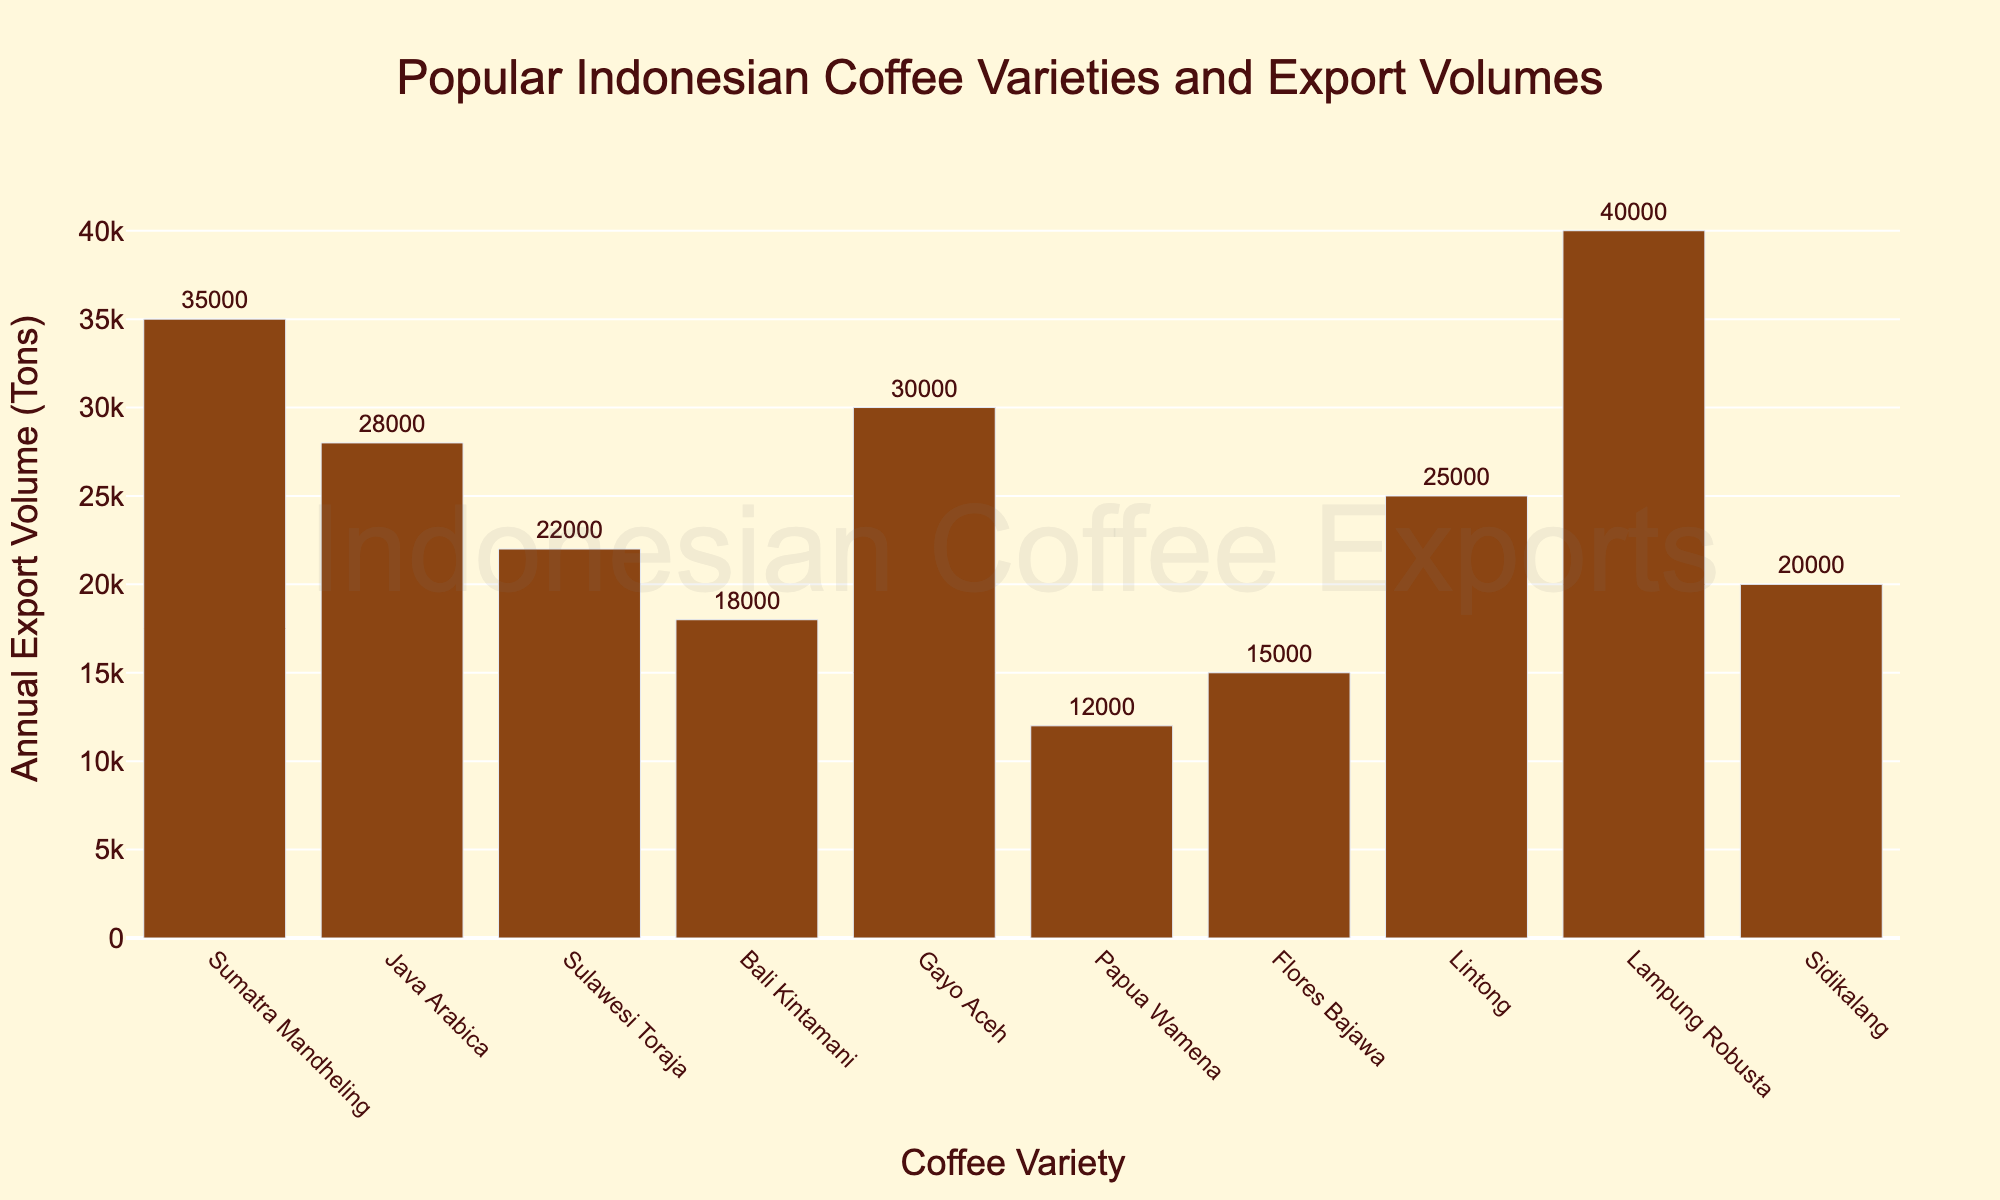Which coffee variety has the highest annual export volume? The bar representing Lampung Robusta is the tallest among all bars, indicating it has the highest export volume.
Answer: Lampung Robusta What's the difference in export volume between Sumatra Mandheling and Sulawesi Toraja? Sumatra Mandheling has an export volume of 35,000 tons and Sulawesi Toraja has 22,000 tons. Subtract the smaller value from the larger one: 35,000 - 22,000 = 13,000.
Answer: 13,000 tons Which coffee varieties have an export volume greater than 30,000 tons? From the chart, Sumatra Mandheling (35,000 tons), Gayo Aceh (30,000 tons), and Lampung Robusta (40,000 tons) have export volumes above 30,000 tons.
Answer: Sumatra Mandheling, Gayo Aceh, Lampung Robusta How does the export volume of Java Arabica compare to Lintong? Java Arabica has an export volume of 28,000 tons, whereas Lintong has 25,000 tons. Java Arabica's export volume is higher by 3,000 tons.
Answer: Java Arabica is 3,000 tons more What is the total export volume for Bali Kintamani and Sidikalang combined? Bali Kintamani has an export volume of 18,000 tons and Sidikalang has 20,000 tons. Adding these together gives 18,000 + 20,000 = 38,000 tons.
Answer: 38,000 tons On average, how many tons do the listed coffee varieties export annually? Summing up all the export volumes (35,000 + 28,000 + 22,000 + 18,000 + 30,000 + 12,000 + 15,000 + 25,000 + 40,000 + 20,000 = 245,000) and dividing by the number of varieties (10), gives an average of 245,000 / 10 = 24,500 tons.
Answer: 24,500 tons Which variety has the shortest bar in the chart and what is its export volume? The shortest bar represents Papua Wamena, which has the lowest export volume of 12,000 tons.
Answer: Papua Wamena, 12,000 tons How much more does Lampung Robusta export annually compared to Bali Kintamani? Lampung Robusta's export volume is 40,000 tons, and Bali Kintamani's is 18,000 tons. The difference is 40,000 - 18,000 = 22,000 tons.
Answer: 22,000 tons If Sidikalang's export volume doubled, how would it compare to Java Arabica's current export volume? Doubling Sidikalang's export volume of 20,000 tons results in 40,000 tons, which is higher by 12,000 tons compared to Java Arabica's 28,000 tons.
Answer: 12,000 tons more 